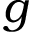<formula> <loc_0><loc_0><loc_500><loc_500>g</formula> 